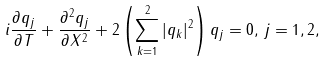<formula> <loc_0><loc_0><loc_500><loc_500>i \frac { \partial q _ { j } } { \partial T } + \frac { \partial ^ { 2 } q _ { j } } { \partial X ^ { 2 } } + 2 \left ( \sum _ { k = 1 } ^ { 2 } | q _ { k } | ^ { 2 } \right ) q _ { j } = 0 , \, j = 1 , 2 ,</formula> 